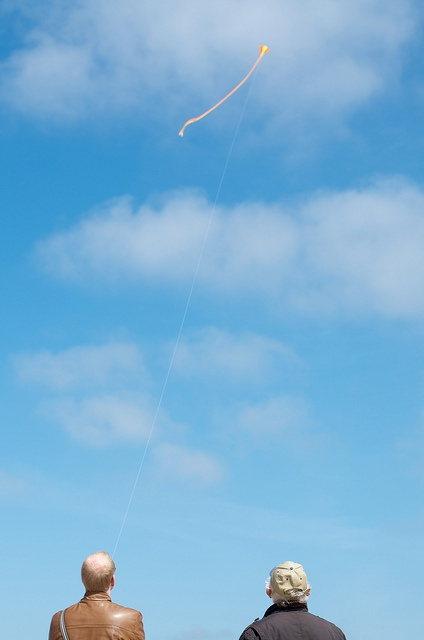Describe the objects in this image and their specific colors. I can see people in gray, tan, and maroon tones, people in gray, black, beige, and tan tones, and kite in gray, lightpink, tan, darkgray, and gold tones in this image. 